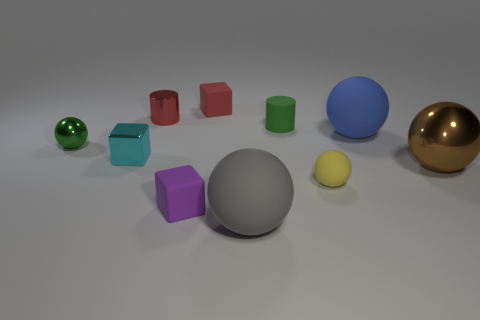There is a block that is left of the rubber cube that is in front of the brown object; what is its material?
Provide a short and direct response. Metal. What material is the brown object that is the same shape as the blue object?
Your answer should be very brief. Metal. There is a block behind the green object that is behind the blue sphere; are there any red cylinders on the left side of it?
Give a very brief answer. Yes. What number of other objects are the same color as the metal cylinder?
Your answer should be very brief. 1. What number of spheres are both behind the purple thing and on the right side of the purple thing?
Provide a succinct answer. 3. The small purple thing is what shape?
Provide a short and direct response. Cube. What number of other things are made of the same material as the big blue object?
Your response must be concise. 5. What color is the tiny sphere behind the tiny ball that is on the right side of the big sphere that is in front of the large brown metallic object?
Offer a terse response. Green. What is the material of the red cylinder that is the same size as the green cylinder?
Keep it short and to the point. Metal. How many objects are either rubber things that are in front of the purple cube or green objects?
Your answer should be very brief. 3. 